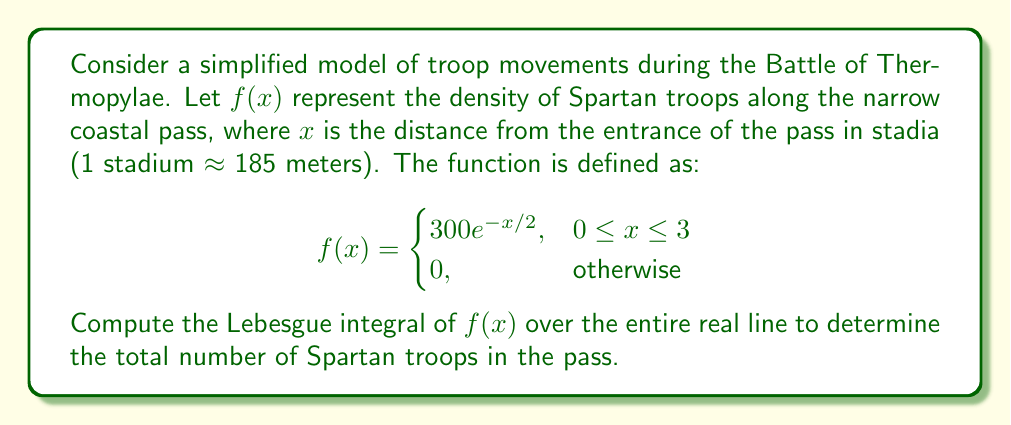Solve this math problem. To compute the Lebesgue integral of $f(x)$ over the entire real line, we need to follow these steps:

1) First, note that $f(x)$ is non-negative and measurable on $\mathbb{R}$, so the Lebesgue integral exists.

2) The function is non-zero only on the interval $[0, 3]$, so we can restrict our integration to this interval:

   $$\int_{\mathbb{R}} f(x) dx = \int_0^3 300e^{-x/2} dx$$

3) To compute this integral, we can use the fundamental theorem of calculus:

   $$\int_0^3 300e^{-x/2} dx = -600e^{-x/2} \bigg|_0^3$$

4) Evaluating the antiderivative at the limits:

   $$-600e^{-x/2} \bigg|_0^3 = -600(e^{-3/2} - e^0)$$

5) Simplify:

   $$-600(e^{-3/2} - 1) = 600(1 - e^{-3/2})$$

6) Calculate the final value:

   $$600(1 - e^{-3/2}) \approx 461.95$$

This result represents the total number of Spartan troops in the pass according to our model. The fact that it's not exactly 300 reflects the simplified nature of the model and the exponential distribution of troops along the pass.
Answer: The Lebesgue integral of $f(x)$ over $\mathbb{R}$ is $600(1 - e^{-3/2}) \approx 461.95$. 